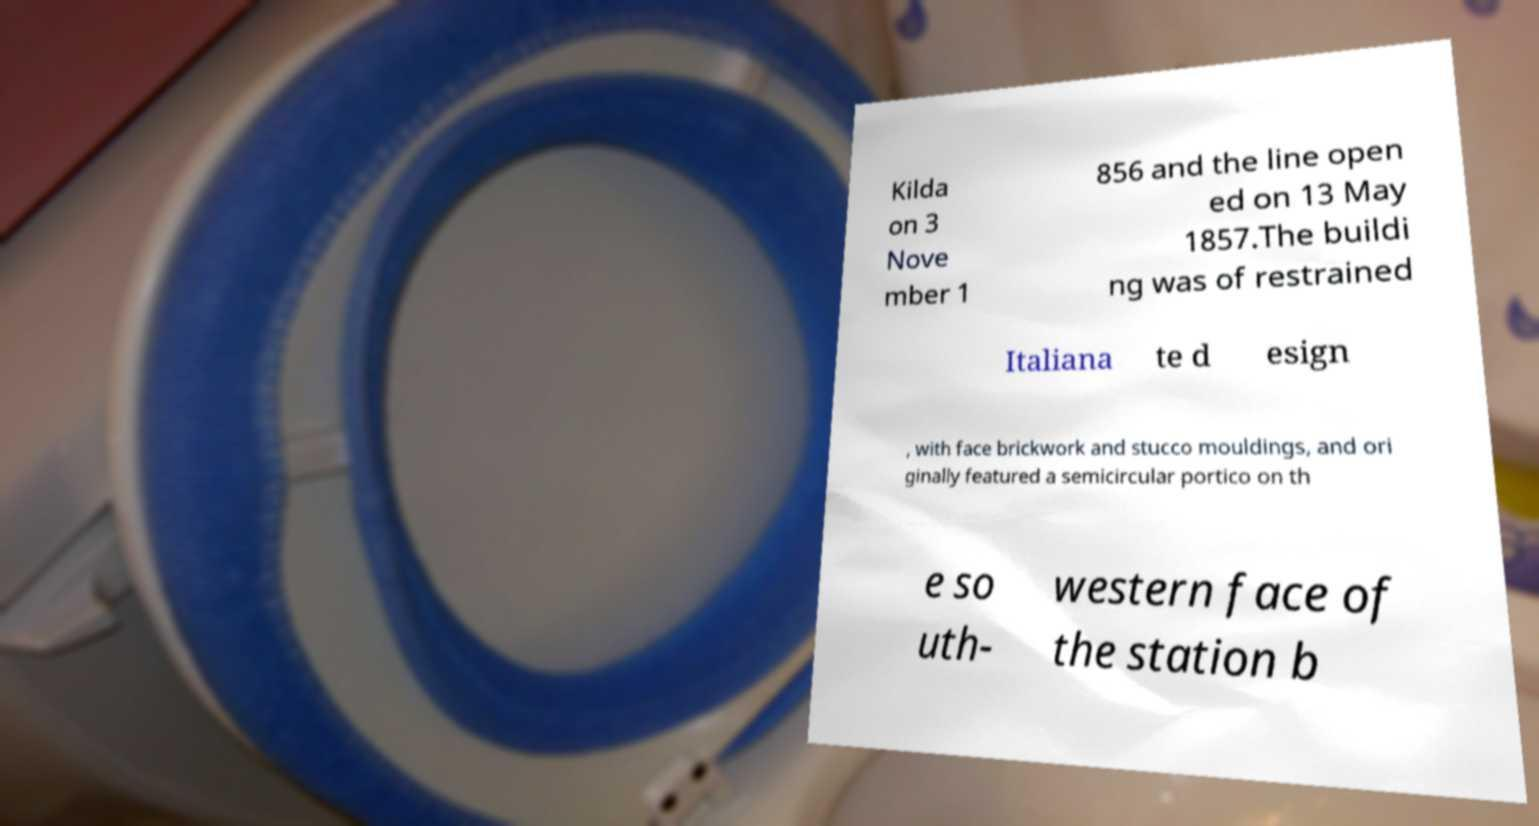Please identify and transcribe the text found in this image. Kilda on 3 Nove mber 1 856 and the line open ed on 13 May 1857.The buildi ng was of restrained Italiana te d esign , with face brickwork and stucco mouldings, and ori ginally featured a semicircular portico on th e so uth- western face of the station b 